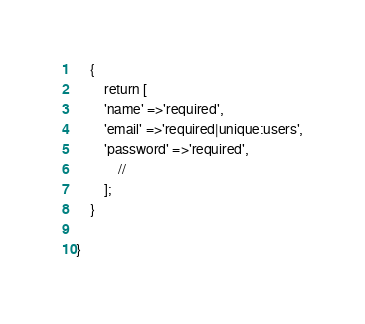Convert code to text. <code><loc_0><loc_0><loc_500><loc_500><_PHP_>	{
		return [
		'name' =>'required',
		'email' =>'required|unique:users',
		'password' =>'required',
			//
		];
	}

}
</code> 